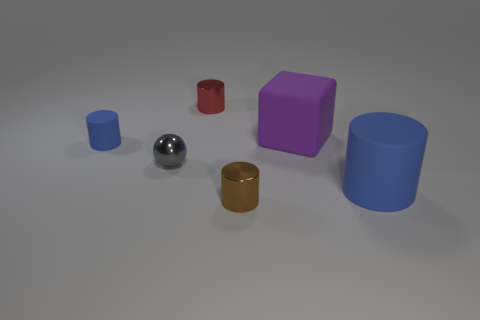Is the color of the small rubber cylinder the same as the big matte cylinder?
Keep it short and to the point. Yes. How many shiny objects are green cylinders or small blue things?
Make the answer very short. 0. Are there any cylinders of the same size as the purple cube?
Offer a very short reply. Yes. What number of blue cylinders have the same size as the gray shiny thing?
Give a very brief answer. 1. There is a rubber cylinder that is right of the tiny brown object; is its size the same as the rubber object behind the tiny blue cylinder?
Offer a very short reply. Yes. How many things are either small spheres or purple blocks that are in front of the small red object?
Make the answer very short. 2. The sphere is what color?
Keep it short and to the point. Gray. What is the material of the small cylinder right of the tiny cylinder that is behind the blue matte object that is on the left side of the brown metallic cylinder?
Your response must be concise. Metal. The gray thing that is the same material as the small red cylinder is what size?
Your answer should be very brief. Small. Are there any other rubber cylinders of the same color as the big rubber cylinder?
Offer a very short reply. Yes. 